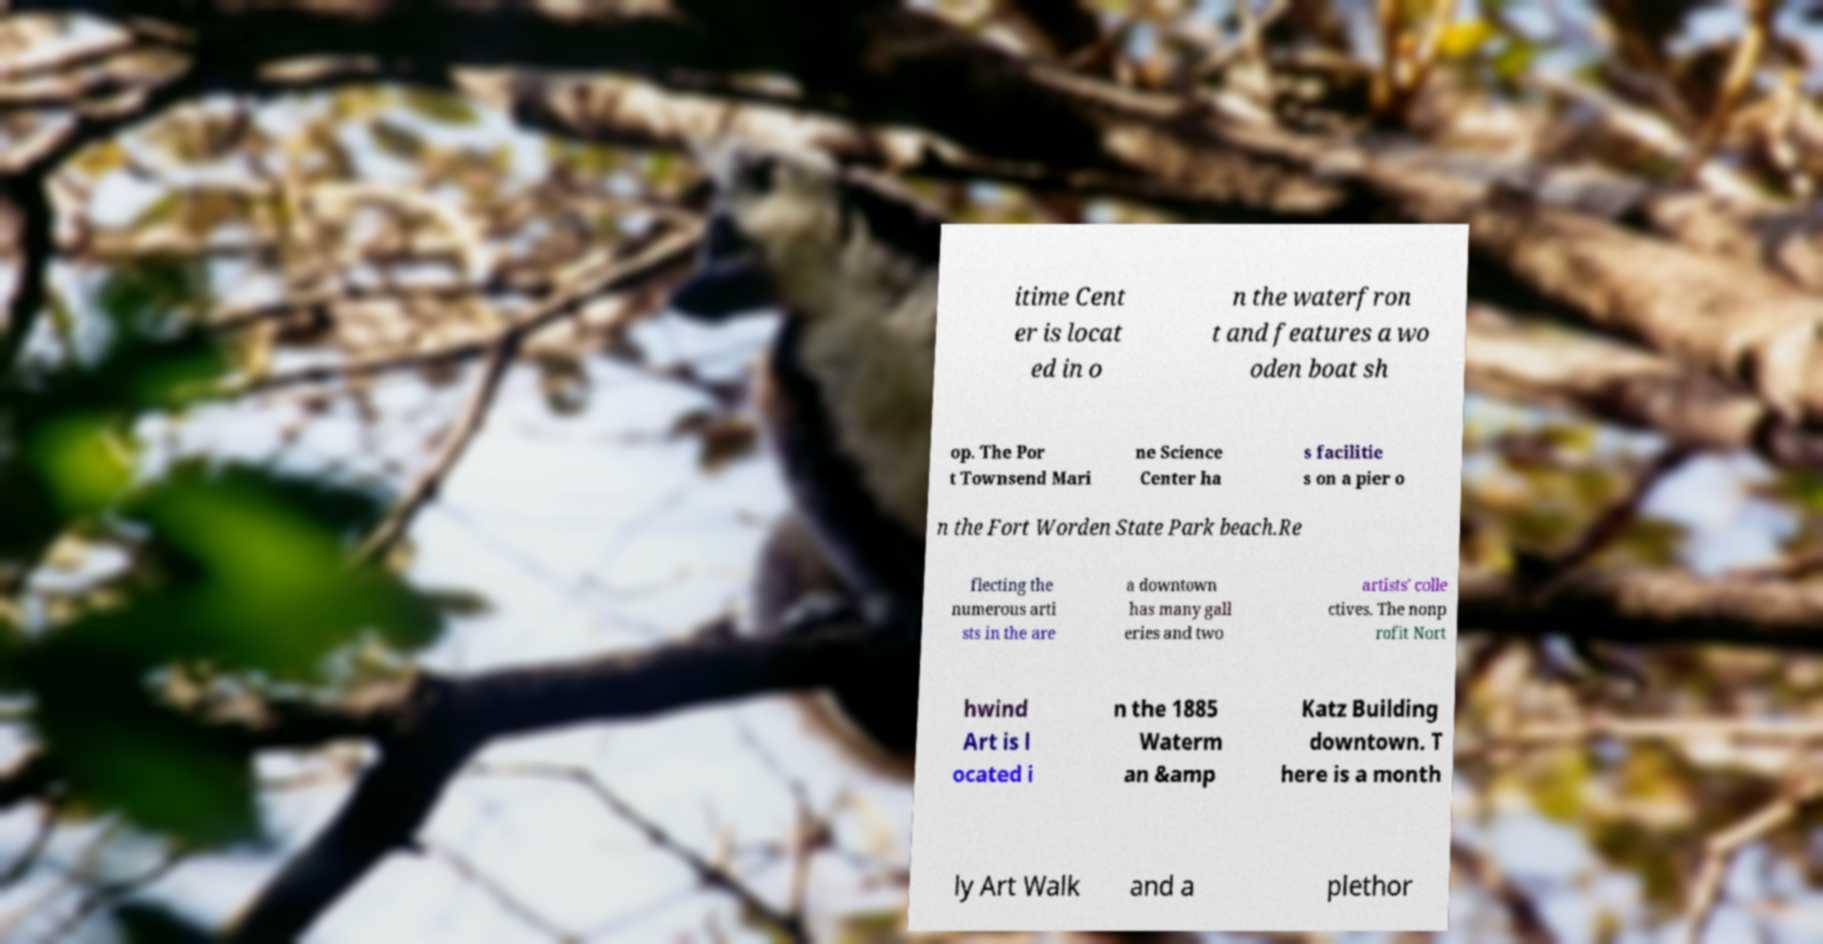Can you read and provide the text displayed in the image?This photo seems to have some interesting text. Can you extract and type it out for me? itime Cent er is locat ed in o n the waterfron t and features a wo oden boat sh op. The Por t Townsend Mari ne Science Center ha s facilitie s on a pier o n the Fort Worden State Park beach.Re flecting the numerous arti sts in the are a downtown has many gall eries and two artists' colle ctives. The nonp rofit Nort hwind Art is l ocated i n the 1885 Waterm an &amp Katz Building downtown. T here is a month ly Art Walk and a plethor 